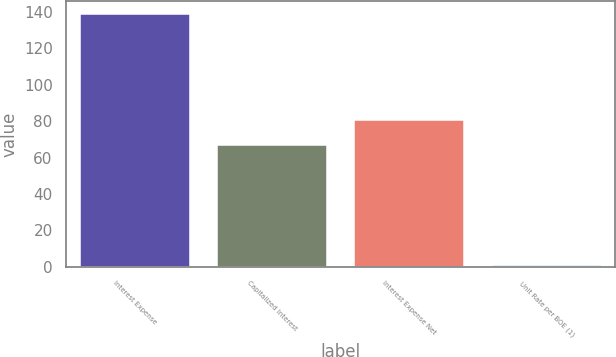<chart> <loc_0><loc_0><loc_500><loc_500><bar_chart><fcel>Interest Expense<fcel>Capitalized Interest<fcel>Interest Expense Net<fcel>Unit Rate per BOE (1)<nl><fcel>139<fcel>67<fcel>80.81<fcel>0.94<nl></chart> 